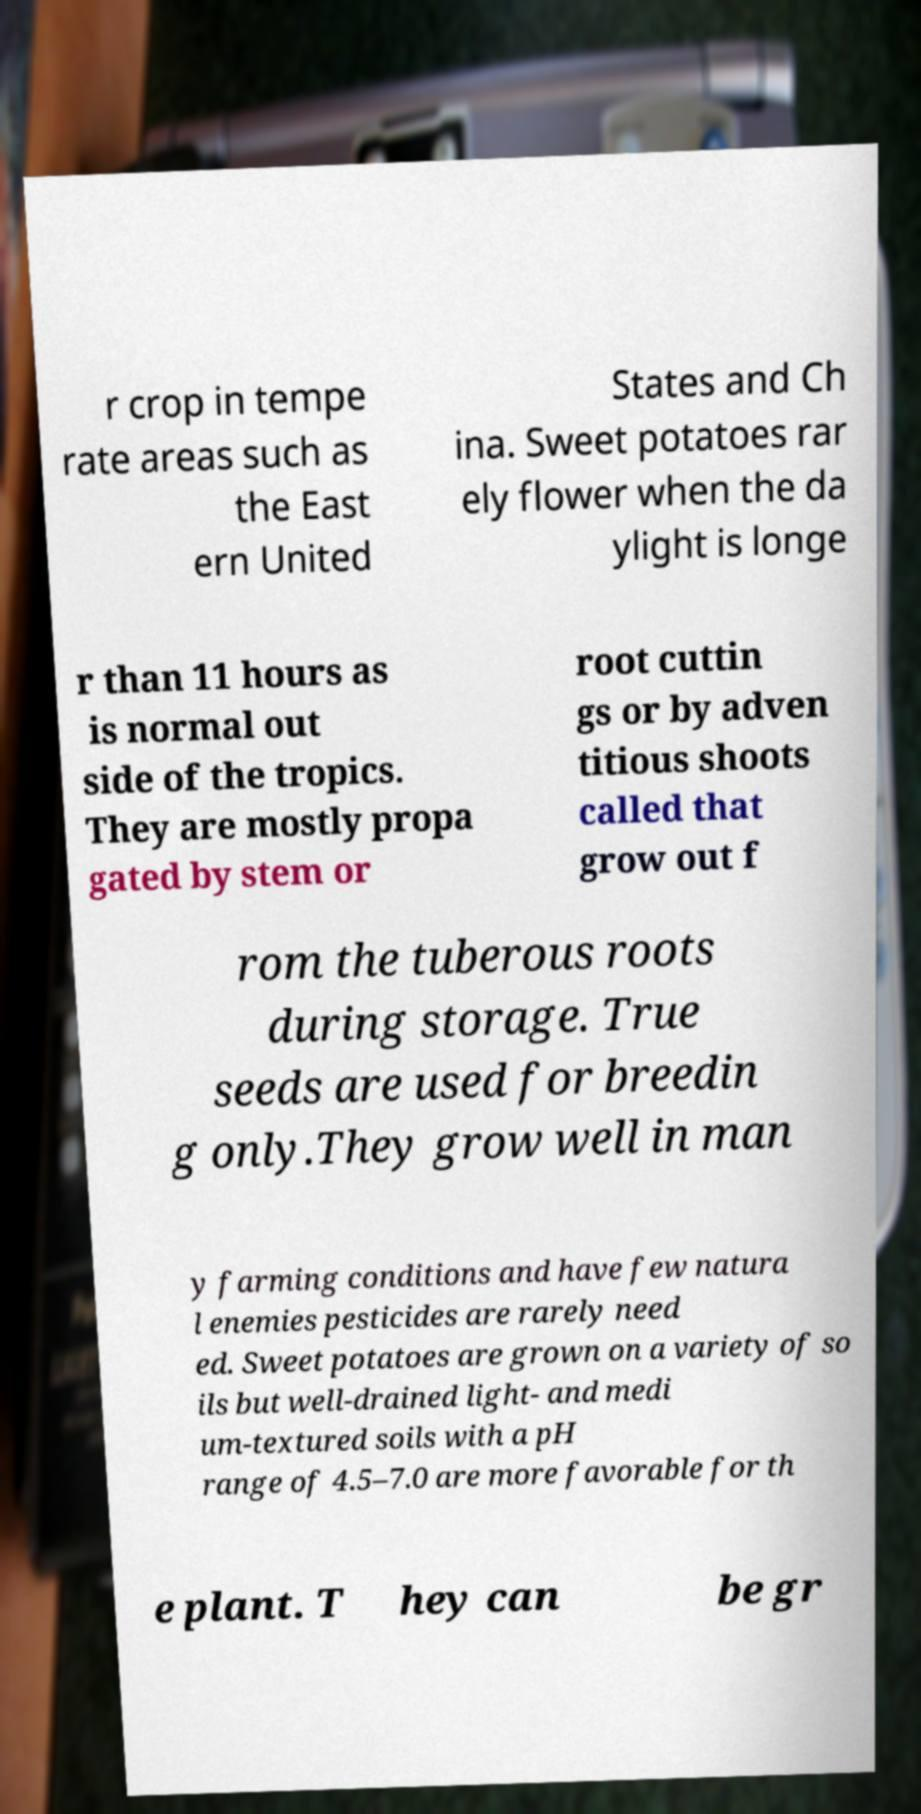Can you accurately transcribe the text from the provided image for me? r crop in tempe rate areas such as the East ern United States and Ch ina. Sweet potatoes rar ely flower when the da ylight is longe r than 11 hours as is normal out side of the tropics. They are mostly propa gated by stem or root cuttin gs or by adven titious shoots called that grow out f rom the tuberous roots during storage. True seeds are used for breedin g only.They grow well in man y farming conditions and have few natura l enemies pesticides are rarely need ed. Sweet potatoes are grown on a variety of so ils but well-drained light- and medi um-textured soils with a pH range of 4.5–7.0 are more favorable for th e plant. T hey can be gr 